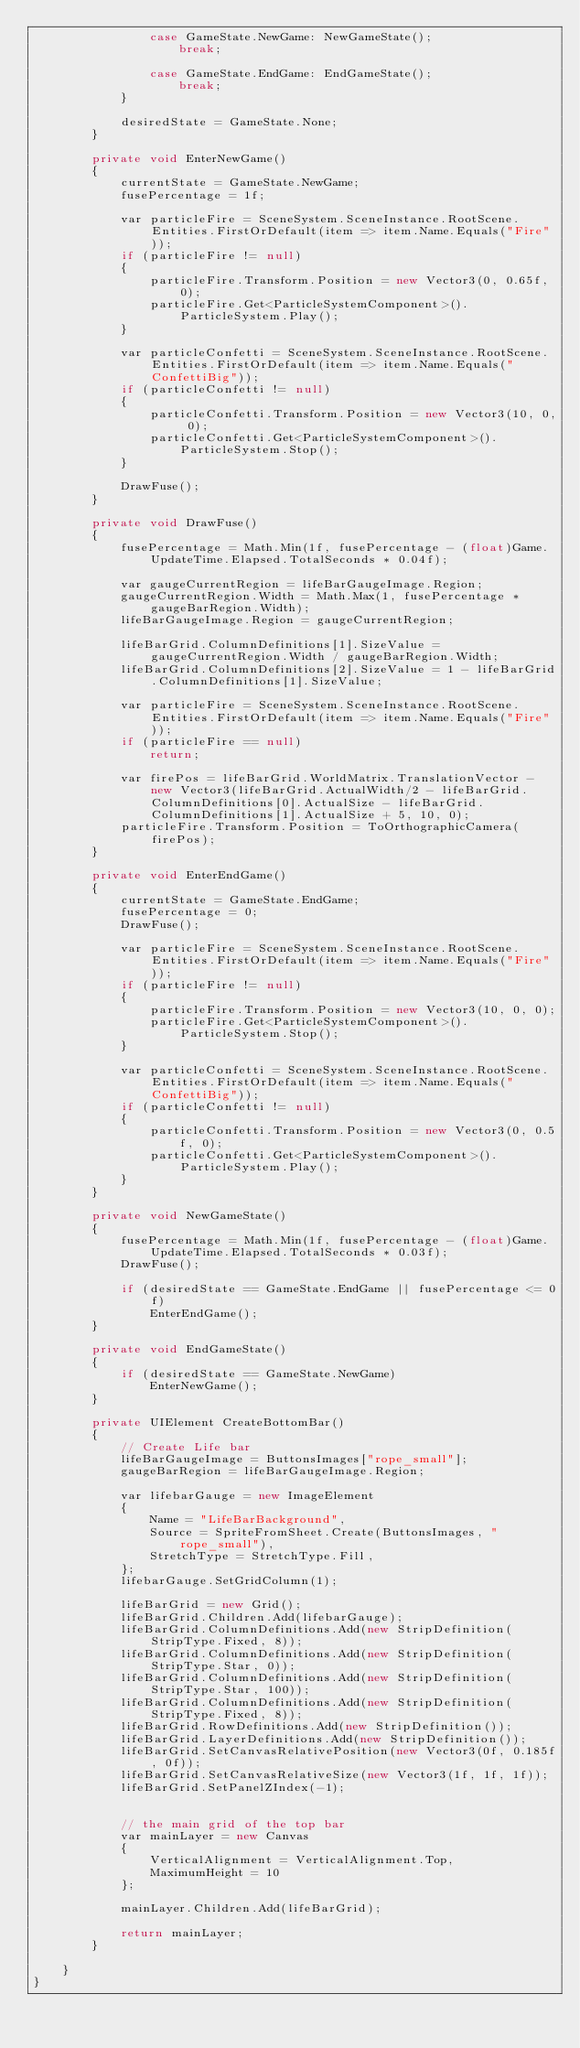Convert code to text. <code><loc_0><loc_0><loc_500><loc_500><_C#_>                case GameState.NewGame: NewGameState();
                    break;

                case GameState.EndGame: EndGameState();
                    break;
            }

            desiredState = GameState.None;
        }

        private void EnterNewGame()
        {
            currentState = GameState.NewGame;
            fusePercentage = 1f;

            var particleFire = SceneSystem.SceneInstance.RootScene.Entities.FirstOrDefault(item => item.Name.Equals("Fire"));
            if (particleFire != null)
            {
                particleFire.Transform.Position = new Vector3(0, 0.65f, 0);
                particleFire.Get<ParticleSystemComponent>().ParticleSystem.Play();
            }

            var particleConfetti = SceneSystem.SceneInstance.RootScene.Entities.FirstOrDefault(item => item.Name.Equals("ConfettiBig"));
            if (particleConfetti != null)
            {
                particleConfetti.Transform.Position = new Vector3(10, 0, 0);
                particleConfetti.Get<ParticleSystemComponent>().ParticleSystem.Stop();
            }

            DrawFuse();
        }

        private void DrawFuse()
        {
            fusePercentage = Math.Min(1f, fusePercentage - (float)Game.UpdateTime.Elapsed.TotalSeconds * 0.04f);

            var gaugeCurrentRegion = lifeBarGaugeImage.Region;
            gaugeCurrentRegion.Width = Math.Max(1, fusePercentage * gaugeBarRegion.Width);
            lifeBarGaugeImage.Region = gaugeCurrentRegion;

            lifeBarGrid.ColumnDefinitions[1].SizeValue = gaugeCurrentRegion.Width / gaugeBarRegion.Width;
            lifeBarGrid.ColumnDefinitions[2].SizeValue = 1 - lifeBarGrid.ColumnDefinitions[1].SizeValue;

            var particleFire = SceneSystem.SceneInstance.RootScene.Entities.FirstOrDefault(item => item.Name.Equals("Fire"));
            if (particleFire == null)
                return;

            var firePos = lifeBarGrid.WorldMatrix.TranslationVector - new Vector3(lifeBarGrid.ActualWidth/2 - lifeBarGrid.ColumnDefinitions[0].ActualSize - lifeBarGrid.ColumnDefinitions[1].ActualSize + 5, 10, 0);
            particleFire.Transform.Position = ToOrthographicCamera(firePos);
        }

        private void EnterEndGame()
        {
            currentState = GameState.EndGame;
            fusePercentage = 0;
            DrawFuse();

            var particleFire = SceneSystem.SceneInstance.RootScene.Entities.FirstOrDefault(item => item.Name.Equals("Fire"));
            if (particleFire != null)
            {
                particleFire.Transform.Position = new Vector3(10, 0, 0);
                particleFire.Get<ParticleSystemComponent>().ParticleSystem.Stop();
            }

            var particleConfetti = SceneSystem.SceneInstance.RootScene.Entities.FirstOrDefault(item => item.Name.Equals("ConfettiBig"));
            if (particleConfetti != null)
            {
                particleConfetti.Transform.Position = new Vector3(0, 0.5f, 0);
                particleConfetti.Get<ParticleSystemComponent>().ParticleSystem.Play();
            }
        }

        private void NewGameState()
        {
            fusePercentage = Math.Min(1f, fusePercentage - (float)Game.UpdateTime.Elapsed.TotalSeconds * 0.03f);
            DrawFuse();

            if (desiredState == GameState.EndGame || fusePercentage <= 0f)
                EnterEndGame();
        }

        private void EndGameState()
        {
            if (desiredState == GameState.NewGame)
                EnterNewGame();
        }

        private UIElement CreateBottomBar()
        {
            // Create Life bar
            lifeBarGaugeImage = ButtonsImages["rope_small"];
            gaugeBarRegion = lifeBarGaugeImage.Region;

            var lifebarGauge = new ImageElement
            {
                Name = "LifeBarBackground",
                Source = SpriteFromSheet.Create(ButtonsImages, "rope_small"),
                StretchType = StretchType.Fill,
            };
            lifebarGauge.SetGridColumn(1);

            lifeBarGrid = new Grid();
            lifeBarGrid.Children.Add(lifebarGauge);
            lifeBarGrid.ColumnDefinitions.Add(new StripDefinition(StripType.Fixed, 8));
            lifeBarGrid.ColumnDefinitions.Add(new StripDefinition(StripType.Star, 0));
            lifeBarGrid.ColumnDefinitions.Add(new StripDefinition(StripType.Star, 100));
            lifeBarGrid.ColumnDefinitions.Add(new StripDefinition(StripType.Fixed, 8));
            lifeBarGrid.RowDefinitions.Add(new StripDefinition());
            lifeBarGrid.LayerDefinitions.Add(new StripDefinition());
            lifeBarGrid.SetCanvasRelativePosition(new Vector3(0f, 0.185f, 0f));
            lifeBarGrid.SetCanvasRelativeSize(new Vector3(1f, 1f, 1f));
            lifeBarGrid.SetPanelZIndex(-1);


            // the main grid of the top bar
            var mainLayer = new Canvas
            {
                VerticalAlignment = VerticalAlignment.Top,
                MaximumHeight = 10
            };

            mainLayer.Children.Add(lifeBarGrid);

            return mainLayer;
        }

    }
}
</code> 